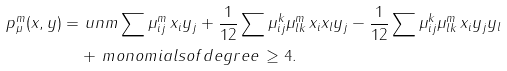Convert formula to latex. <formula><loc_0><loc_0><loc_500><loc_500>p _ { \mu } ^ { m } ( x , y ) = & \ u n m \sum \mu _ { i j } ^ { m } \, x _ { i } y _ { j } + \frac { 1 } { 1 2 } \sum \mu _ { i j } ^ { k } \mu _ { l k } ^ { m } \, x _ { i } x _ { l } y _ { j } - \frac { 1 } { 1 2 } \sum \mu _ { i j } ^ { k } \mu _ { l k } ^ { m } \, x _ { i } y _ { j } y _ { l } \\ & + \, m o n o m i a l s o f d e g r e e \, \geq 4 .</formula> 